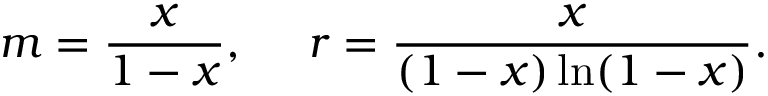<formula> <loc_0><loc_0><loc_500><loc_500>m = \frac { x } { 1 - x } , r = \frac { x } { ( 1 - x ) \ln ( 1 - x ) } .</formula> 